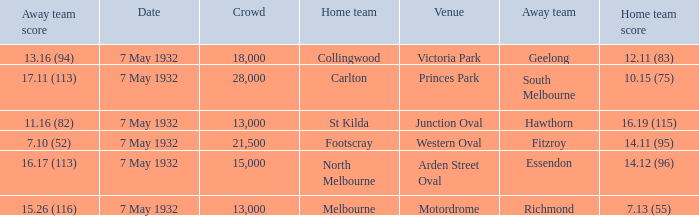What is the home team for victoria park? Collingwood. 